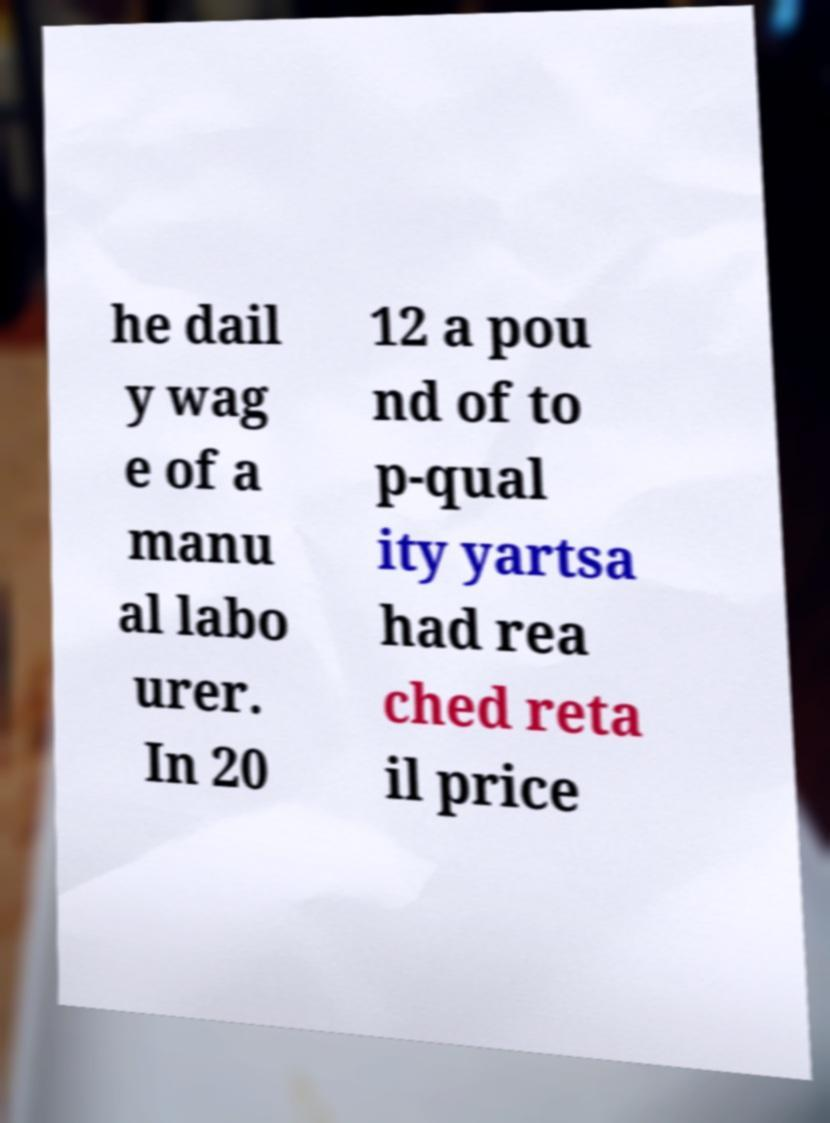What messages or text are displayed in this image? I need them in a readable, typed format. he dail y wag e of a manu al labo urer. In 20 12 a pou nd of to p-qual ity yartsa had rea ched reta il price 